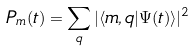Convert formula to latex. <formula><loc_0><loc_0><loc_500><loc_500>P _ { m } ( t ) = \sum _ { q } | \langle m , q | \Psi ( t ) \rangle | ^ { 2 }</formula> 